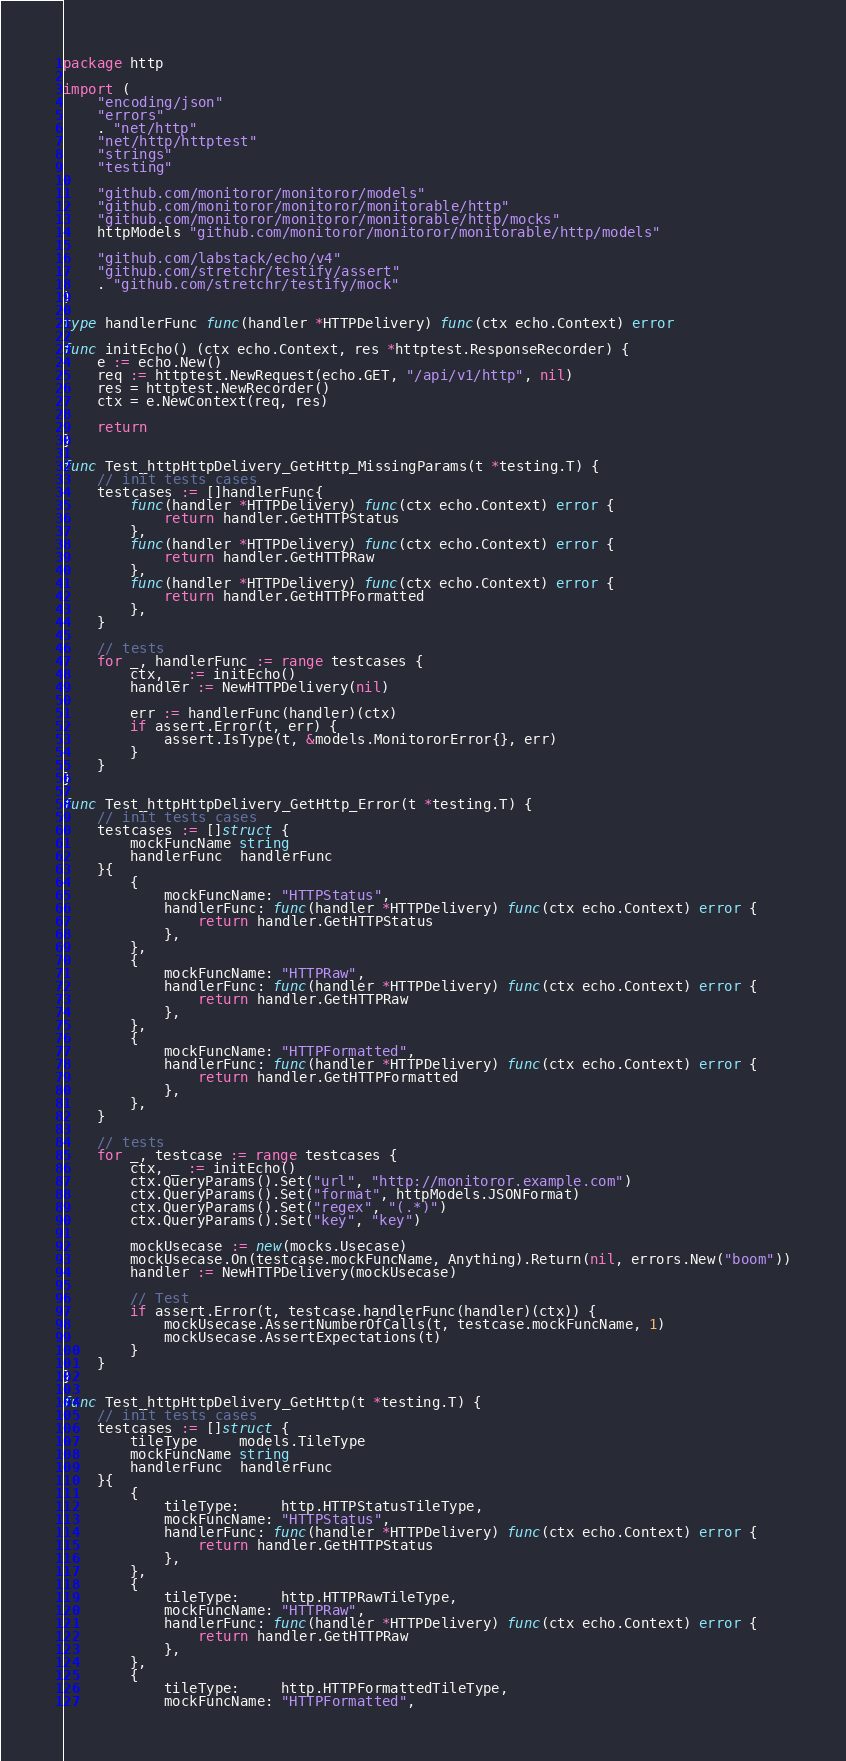Convert code to text. <code><loc_0><loc_0><loc_500><loc_500><_Go_>package http

import (
	"encoding/json"
	"errors"
	. "net/http"
	"net/http/httptest"
	"strings"
	"testing"

	"github.com/monitoror/monitoror/models"
	"github.com/monitoror/monitoror/monitorable/http"
	"github.com/monitoror/monitoror/monitorable/http/mocks"
	httpModels "github.com/monitoror/monitoror/monitorable/http/models"

	"github.com/labstack/echo/v4"
	"github.com/stretchr/testify/assert"
	. "github.com/stretchr/testify/mock"
)

type handlerFunc func(handler *HTTPDelivery) func(ctx echo.Context) error

func initEcho() (ctx echo.Context, res *httptest.ResponseRecorder) {
	e := echo.New()
	req := httptest.NewRequest(echo.GET, "/api/v1/http", nil)
	res = httptest.NewRecorder()
	ctx = e.NewContext(req, res)

	return
}

func Test_httpHttpDelivery_GetHttp_MissingParams(t *testing.T) {
	// init tests cases
	testcases := []handlerFunc{
		func(handler *HTTPDelivery) func(ctx echo.Context) error {
			return handler.GetHTTPStatus
		},
		func(handler *HTTPDelivery) func(ctx echo.Context) error {
			return handler.GetHTTPRaw
		},
		func(handler *HTTPDelivery) func(ctx echo.Context) error {
			return handler.GetHTTPFormatted
		},
	}

	// tests
	for _, handlerFunc := range testcases {
		ctx, _ := initEcho()
		handler := NewHTTPDelivery(nil)

		err := handlerFunc(handler)(ctx)
		if assert.Error(t, err) {
			assert.IsType(t, &models.MonitororError{}, err)
		}
	}
}

func Test_httpHttpDelivery_GetHttp_Error(t *testing.T) {
	// init tests cases
	testcases := []struct {
		mockFuncName string
		handlerFunc  handlerFunc
	}{
		{
			mockFuncName: "HTTPStatus",
			handlerFunc: func(handler *HTTPDelivery) func(ctx echo.Context) error {
				return handler.GetHTTPStatus
			},
		},
		{
			mockFuncName: "HTTPRaw",
			handlerFunc: func(handler *HTTPDelivery) func(ctx echo.Context) error {
				return handler.GetHTTPRaw
			},
		},
		{
			mockFuncName: "HTTPFormatted",
			handlerFunc: func(handler *HTTPDelivery) func(ctx echo.Context) error {
				return handler.GetHTTPFormatted
			},
		},
	}

	// tests
	for _, testcase := range testcases {
		ctx, _ := initEcho()
		ctx.QueryParams().Set("url", "http://monitoror.example.com")
		ctx.QueryParams().Set("format", httpModels.JSONFormat)
		ctx.QueryParams().Set("regex", "(.*)")
		ctx.QueryParams().Set("key", "key")

		mockUsecase := new(mocks.Usecase)
		mockUsecase.On(testcase.mockFuncName, Anything).Return(nil, errors.New("boom"))
		handler := NewHTTPDelivery(mockUsecase)

		// Test
		if assert.Error(t, testcase.handlerFunc(handler)(ctx)) {
			mockUsecase.AssertNumberOfCalls(t, testcase.mockFuncName, 1)
			mockUsecase.AssertExpectations(t)
		}
	}
}

func Test_httpHttpDelivery_GetHttp(t *testing.T) {
	// init tests cases
	testcases := []struct {
		tileType     models.TileType
		mockFuncName string
		handlerFunc  handlerFunc
	}{
		{
			tileType:     http.HTTPStatusTileType,
			mockFuncName: "HTTPStatus",
			handlerFunc: func(handler *HTTPDelivery) func(ctx echo.Context) error {
				return handler.GetHTTPStatus
			},
		},
		{
			tileType:     http.HTTPRawTileType,
			mockFuncName: "HTTPRaw",
			handlerFunc: func(handler *HTTPDelivery) func(ctx echo.Context) error {
				return handler.GetHTTPRaw
			},
		},
		{
			tileType:     http.HTTPFormattedTileType,
			mockFuncName: "HTTPFormatted",</code> 